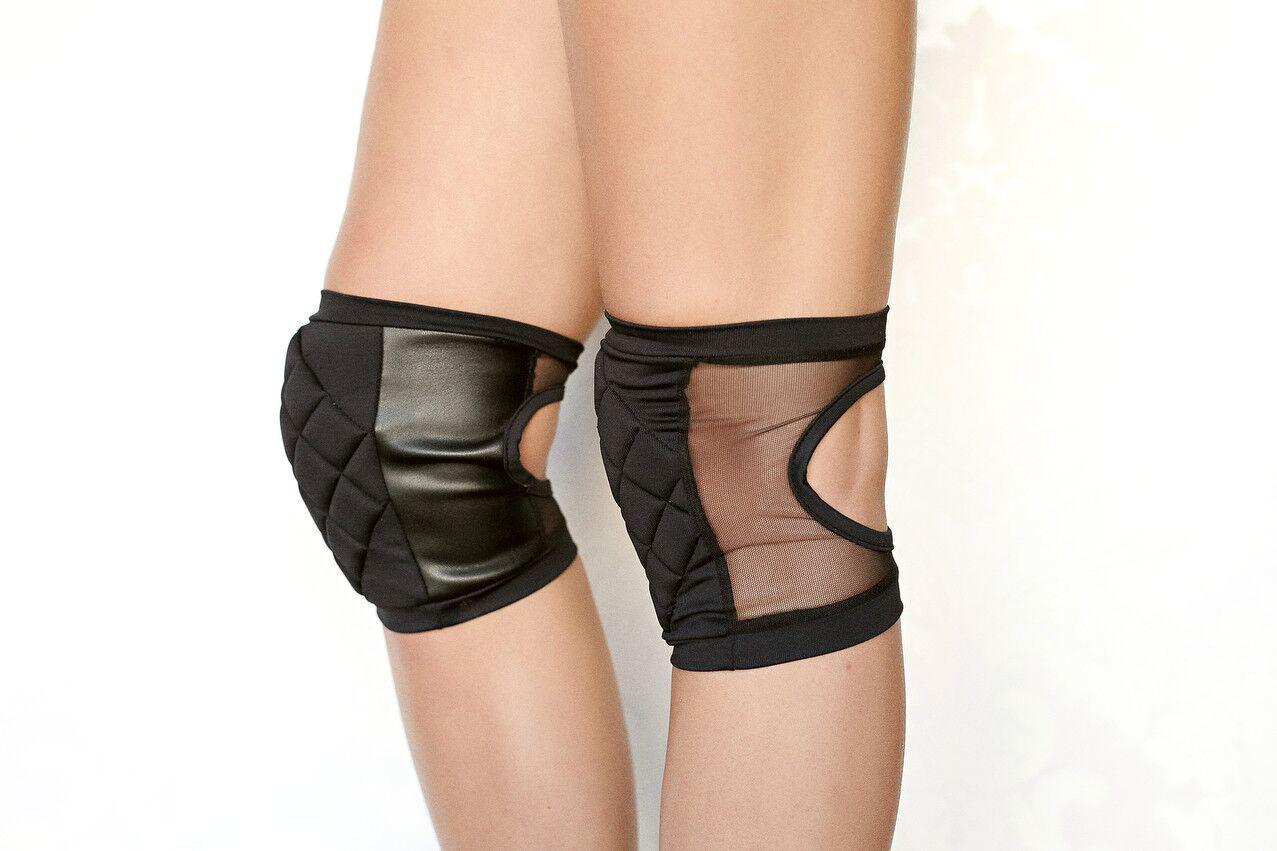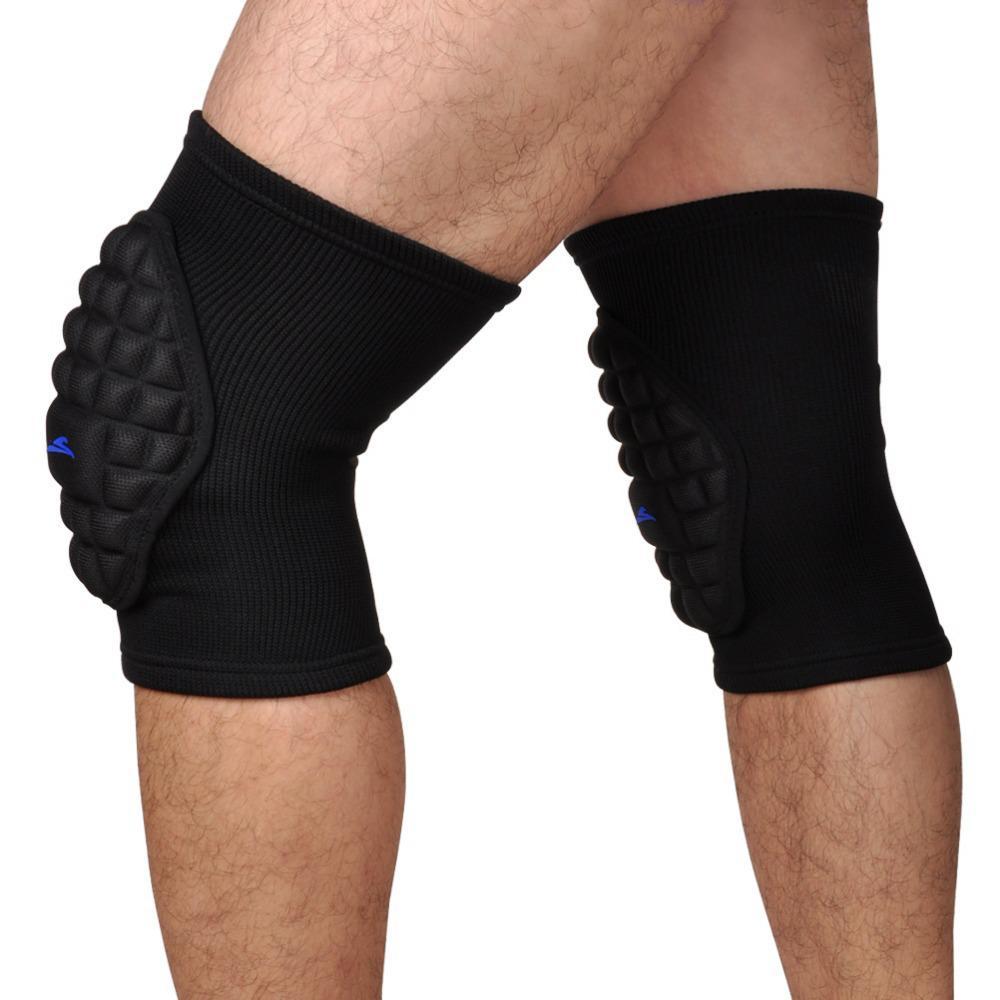The first image is the image on the left, the second image is the image on the right. Analyze the images presented: Is the assertion "Only black kneepads are shown, and the left and right images contain the same number of kneepads." valid? Answer yes or no. Yes. 